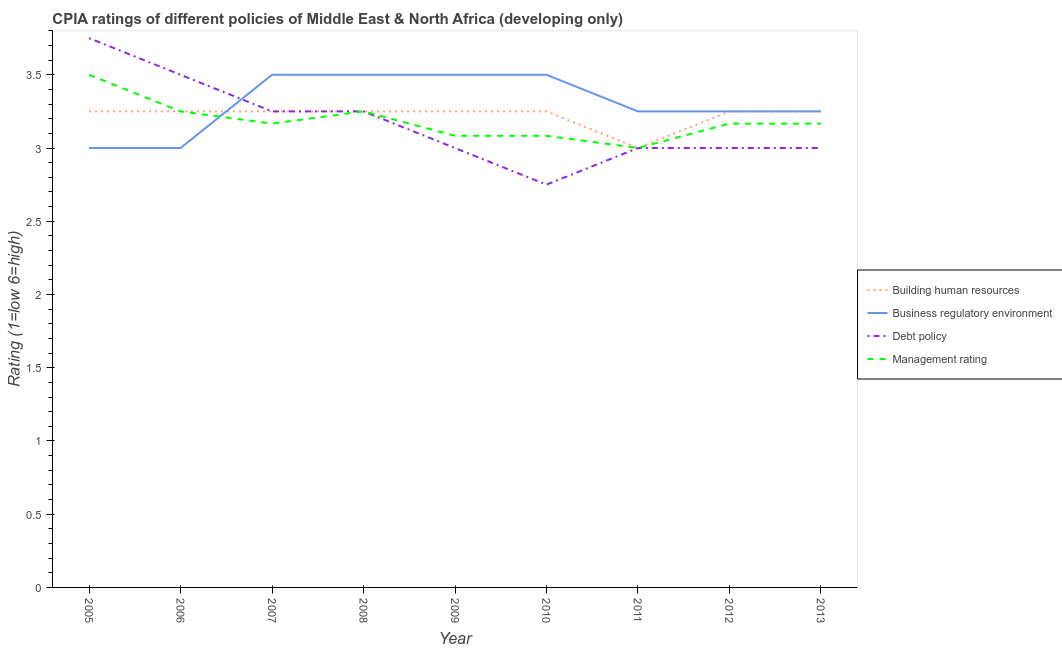Does the line corresponding to cpia rating of business regulatory environment intersect with the line corresponding to cpia rating of debt policy?
Your answer should be very brief. Yes. Across all years, what is the minimum cpia rating of management?
Your response must be concise. 3. In which year was the cpia rating of debt policy minimum?
Make the answer very short. 2010. What is the difference between the cpia rating of management in 2005 and that in 2009?
Provide a succinct answer. 0.42. What is the average cpia rating of management per year?
Your response must be concise. 3.19. In how many years, is the cpia rating of building human resources greater than 2.6?
Ensure brevity in your answer.  9. What is the ratio of the cpia rating of business regulatory environment in 2006 to that in 2011?
Provide a succinct answer. 0.92. Is the cpia rating of building human resources in 2007 less than that in 2009?
Your answer should be compact. No. Is the difference between the cpia rating of debt policy in 2008 and 2009 greater than the difference between the cpia rating of building human resources in 2008 and 2009?
Offer a very short reply. Yes. What is the difference between the highest and the second highest cpia rating of management?
Ensure brevity in your answer.  0.25. What is the difference between the highest and the lowest cpia rating of building human resources?
Ensure brevity in your answer.  0.25. In how many years, is the cpia rating of management greater than the average cpia rating of management taken over all years?
Give a very brief answer. 3. Is the sum of the cpia rating of debt policy in 2007 and 2010 greater than the maximum cpia rating of business regulatory environment across all years?
Offer a very short reply. Yes. How many lines are there?
Your answer should be compact. 4. Are the values on the major ticks of Y-axis written in scientific E-notation?
Give a very brief answer. No. Does the graph contain any zero values?
Your answer should be compact. No. Does the graph contain grids?
Ensure brevity in your answer.  No. Where does the legend appear in the graph?
Provide a succinct answer. Center right. How are the legend labels stacked?
Offer a very short reply. Vertical. What is the title of the graph?
Keep it short and to the point. CPIA ratings of different policies of Middle East & North Africa (developing only). Does "Public resource use" appear as one of the legend labels in the graph?
Give a very brief answer. No. What is the label or title of the X-axis?
Provide a succinct answer. Year. What is the Rating (1=low 6=high) in Building human resources in 2005?
Give a very brief answer. 3.25. What is the Rating (1=low 6=high) in Debt policy in 2005?
Make the answer very short. 3.75. What is the Rating (1=low 6=high) of Building human resources in 2006?
Make the answer very short. 3.25. What is the Rating (1=low 6=high) of Business regulatory environment in 2007?
Provide a short and direct response. 3.5. What is the Rating (1=low 6=high) of Management rating in 2007?
Make the answer very short. 3.17. What is the Rating (1=low 6=high) in Building human resources in 2008?
Offer a terse response. 3.25. What is the Rating (1=low 6=high) of Debt policy in 2008?
Provide a short and direct response. 3.25. What is the Rating (1=low 6=high) of Management rating in 2008?
Your answer should be very brief. 3.25. What is the Rating (1=low 6=high) of Building human resources in 2009?
Your response must be concise. 3.25. What is the Rating (1=low 6=high) in Debt policy in 2009?
Offer a very short reply. 3. What is the Rating (1=low 6=high) of Management rating in 2009?
Keep it short and to the point. 3.08. What is the Rating (1=low 6=high) in Building human resources in 2010?
Offer a terse response. 3.25. What is the Rating (1=low 6=high) of Debt policy in 2010?
Provide a short and direct response. 2.75. What is the Rating (1=low 6=high) of Management rating in 2010?
Offer a terse response. 3.08. What is the Rating (1=low 6=high) in Building human resources in 2011?
Offer a very short reply. 3. What is the Rating (1=low 6=high) in Business regulatory environment in 2011?
Provide a short and direct response. 3.25. What is the Rating (1=low 6=high) in Debt policy in 2011?
Make the answer very short. 3. What is the Rating (1=low 6=high) of Business regulatory environment in 2012?
Make the answer very short. 3.25. What is the Rating (1=low 6=high) in Management rating in 2012?
Offer a very short reply. 3.17. What is the Rating (1=low 6=high) in Management rating in 2013?
Provide a succinct answer. 3.17. Across all years, what is the maximum Rating (1=low 6=high) in Business regulatory environment?
Make the answer very short. 3.5. Across all years, what is the maximum Rating (1=low 6=high) of Debt policy?
Provide a succinct answer. 3.75. Across all years, what is the minimum Rating (1=low 6=high) of Debt policy?
Offer a terse response. 2.75. What is the total Rating (1=low 6=high) of Business regulatory environment in the graph?
Keep it short and to the point. 29.75. What is the total Rating (1=low 6=high) in Debt policy in the graph?
Provide a short and direct response. 28.5. What is the total Rating (1=low 6=high) of Management rating in the graph?
Provide a short and direct response. 28.67. What is the difference between the Rating (1=low 6=high) of Building human resources in 2005 and that in 2006?
Keep it short and to the point. 0. What is the difference between the Rating (1=low 6=high) in Business regulatory environment in 2005 and that in 2007?
Keep it short and to the point. -0.5. What is the difference between the Rating (1=low 6=high) of Business regulatory environment in 2005 and that in 2008?
Keep it short and to the point. -0.5. What is the difference between the Rating (1=low 6=high) of Management rating in 2005 and that in 2008?
Your answer should be very brief. 0.25. What is the difference between the Rating (1=low 6=high) of Building human resources in 2005 and that in 2009?
Your answer should be very brief. 0. What is the difference between the Rating (1=low 6=high) in Business regulatory environment in 2005 and that in 2009?
Your answer should be compact. -0.5. What is the difference between the Rating (1=low 6=high) of Management rating in 2005 and that in 2009?
Provide a succinct answer. 0.42. What is the difference between the Rating (1=low 6=high) in Business regulatory environment in 2005 and that in 2010?
Offer a very short reply. -0.5. What is the difference between the Rating (1=low 6=high) in Debt policy in 2005 and that in 2010?
Offer a terse response. 1. What is the difference between the Rating (1=low 6=high) of Management rating in 2005 and that in 2010?
Keep it short and to the point. 0.42. What is the difference between the Rating (1=low 6=high) in Debt policy in 2005 and that in 2011?
Give a very brief answer. 0.75. What is the difference between the Rating (1=low 6=high) of Management rating in 2005 and that in 2011?
Give a very brief answer. 0.5. What is the difference between the Rating (1=low 6=high) of Building human resources in 2005 and that in 2012?
Give a very brief answer. 0. What is the difference between the Rating (1=low 6=high) of Management rating in 2005 and that in 2013?
Offer a terse response. 0.33. What is the difference between the Rating (1=low 6=high) of Business regulatory environment in 2006 and that in 2007?
Your response must be concise. -0.5. What is the difference between the Rating (1=low 6=high) in Debt policy in 2006 and that in 2007?
Make the answer very short. 0.25. What is the difference between the Rating (1=low 6=high) in Management rating in 2006 and that in 2007?
Make the answer very short. 0.08. What is the difference between the Rating (1=low 6=high) in Building human resources in 2006 and that in 2008?
Ensure brevity in your answer.  0. What is the difference between the Rating (1=low 6=high) in Business regulatory environment in 2006 and that in 2008?
Provide a succinct answer. -0.5. What is the difference between the Rating (1=low 6=high) of Management rating in 2006 and that in 2008?
Give a very brief answer. 0. What is the difference between the Rating (1=low 6=high) in Building human resources in 2006 and that in 2009?
Keep it short and to the point. 0. What is the difference between the Rating (1=low 6=high) in Business regulatory environment in 2006 and that in 2009?
Ensure brevity in your answer.  -0.5. What is the difference between the Rating (1=low 6=high) of Management rating in 2006 and that in 2009?
Provide a short and direct response. 0.17. What is the difference between the Rating (1=low 6=high) in Debt policy in 2006 and that in 2010?
Your answer should be compact. 0.75. What is the difference between the Rating (1=low 6=high) of Management rating in 2006 and that in 2010?
Provide a short and direct response. 0.17. What is the difference between the Rating (1=low 6=high) of Building human resources in 2006 and that in 2011?
Your answer should be very brief. 0.25. What is the difference between the Rating (1=low 6=high) of Debt policy in 2006 and that in 2011?
Offer a terse response. 0.5. What is the difference between the Rating (1=low 6=high) in Debt policy in 2006 and that in 2012?
Give a very brief answer. 0.5. What is the difference between the Rating (1=low 6=high) of Management rating in 2006 and that in 2012?
Make the answer very short. 0.08. What is the difference between the Rating (1=low 6=high) in Building human resources in 2006 and that in 2013?
Provide a short and direct response. 0. What is the difference between the Rating (1=low 6=high) of Business regulatory environment in 2006 and that in 2013?
Your answer should be very brief. -0.25. What is the difference between the Rating (1=low 6=high) in Management rating in 2006 and that in 2013?
Make the answer very short. 0.08. What is the difference between the Rating (1=low 6=high) in Business regulatory environment in 2007 and that in 2008?
Give a very brief answer. 0. What is the difference between the Rating (1=low 6=high) in Management rating in 2007 and that in 2008?
Keep it short and to the point. -0.08. What is the difference between the Rating (1=low 6=high) of Management rating in 2007 and that in 2009?
Provide a short and direct response. 0.08. What is the difference between the Rating (1=low 6=high) of Building human resources in 2007 and that in 2010?
Your answer should be very brief. 0. What is the difference between the Rating (1=low 6=high) of Business regulatory environment in 2007 and that in 2010?
Keep it short and to the point. 0. What is the difference between the Rating (1=low 6=high) of Management rating in 2007 and that in 2010?
Your answer should be compact. 0.08. What is the difference between the Rating (1=low 6=high) of Debt policy in 2007 and that in 2011?
Your answer should be very brief. 0.25. What is the difference between the Rating (1=low 6=high) of Building human resources in 2007 and that in 2012?
Offer a very short reply. 0. What is the difference between the Rating (1=low 6=high) in Business regulatory environment in 2007 and that in 2012?
Provide a succinct answer. 0.25. What is the difference between the Rating (1=low 6=high) of Management rating in 2007 and that in 2012?
Offer a very short reply. 0. What is the difference between the Rating (1=low 6=high) of Debt policy in 2007 and that in 2013?
Your answer should be very brief. 0.25. What is the difference between the Rating (1=low 6=high) in Debt policy in 2008 and that in 2009?
Give a very brief answer. 0.25. What is the difference between the Rating (1=low 6=high) of Business regulatory environment in 2008 and that in 2010?
Offer a terse response. 0. What is the difference between the Rating (1=low 6=high) of Debt policy in 2008 and that in 2010?
Ensure brevity in your answer.  0.5. What is the difference between the Rating (1=low 6=high) of Management rating in 2008 and that in 2010?
Your answer should be compact. 0.17. What is the difference between the Rating (1=low 6=high) in Building human resources in 2008 and that in 2011?
Offer a very short reply. 0.25. What is the difference between the Rating (1=low 6=high) of Business regulatory environment in 2008 and that in 2011?
Make the answer very short. 0.25. What is the difference between the Rating (1=low 6=high) in Building human resources in 2008 and that in 2012?
Provide a succinct answer. 0. What is the difference between the Rating (1=low 6=high) of Business regulatory environment in 2008 and that in 2012?
Give a very brief answer. 0.25. What is the difference between the Rating (1=low 6=high) in Management rating in 2008 and that in 2012?
Provide a short and direct response. 0.08. What is the difference between the Rating (1=low 6=high) of Management rating in 2008 and that in 2013?
Give a very brief answer. 0.08. What is the difference between the Rating (1=low 6=high) of Debt policy in 2009 and that in 2010?
Offer a terse response. 0.25. What is the difference between the Rating (1=low 6=high) in Building human resources in 2009 and that in 2011?
Provide a succinct answer. 0.25. What is the difference between the Rating (1=low 6=high) of Management rating in 2009 and that in 2011?
Your response must be concise. 0.08. What is the difference between the Rating (1=low 6=high) of Building human resources in 2009 and that in 2012?
Give a very brief answer. 0. What is the difference between the Rating (1=low 6=high) in Management rating in 2009 and that in 2012?
Your answer should be compact. -0.08. What is the difference between the Rating (1=low 6=high) in Management rating in 2009 and that in 2013?
Provide a succinct answer. -0.08. What is the difference between the Rating (1=low 6=high) of Debt policy in 2010 and that in 2011?
Offer a very short reply. -0.25. What is the difference between the Rating (1=low 6=high) in Management rating in 2010 and that in 2011?
Provide a succinct answer. 0.08. What is the difference between the Rating (1=low 6=high) in Business regulatory environment in 2010 and that in 2012?
Offer a very short reply. 0.25. What is the difference between the Rating (1=low 6=high) of Debt policy in 2010 and that in 2012?
Provide a short and direct response. -0.25. What is the difference between the Rating (1=low 6=high) in Management rating in 2010 and that in 2012?
Keep it short and to the point. -0.08. What is the difference between the Rating (1=low 6=high) in Business regulatory environment in 2010 and that in 2013?
Provide a short and direct response. 0.25. What is the difference between the Rating (1=low 6=high) in Management rating in 2010 and that in 2013?
Your answer should be very brief. -0.08. What is the difference between the Rating (1=low 6=high) of Building human resources in 2011 and that in 2012?
Offer a terse response. -0.25. What is the difference between the Rating (1=low 6=high) of Business regulatory environment in 2011 and that in 2012?
Keep it short and to the point. 0. What is the difference between the Rating (1=low 6=high) in Debt policy in 2011 and that in 2012?
Provide a short and direct response. 0. What is the difference between the Rating (1=low 6=high) of Building human resources in 2011 and that in 2013?
Ensure brevity in your answer.  -0.25. What is the difference between the Rating (1=low 6=high) in Management rating in 2011 and that in 2013?
Your answer should be compact. -0.17. What is the difference between the Rating (1=low 6=high) in Building human resources in 2012 and that in 2013?
Your answer should be compact. 0. What is the difference between the Rating (1=low 6=high) in Business regulatory environment in 2012 and that in 2013?
Your answer should be compact. 0. What is the difference between the Rating (1=low 6=high) in Debt policy in 2012 and that in 2013?
Ensure brevity in your answer.  0. What is the difference between the Rating (1=low 6=high) in Management rating in 2012 and that in 2013?
Make the answer very short. 0. What is the difference between the Rating (1=low 6=high) of Building human resources in 2005 and the Rating (1=low 6=high) of Business regulatory environment in 2006?
Provide a short and direct response. 0.25. What is the difference between the Rating (1=low 6=high) in Building human resources in 2005 and the Rating (1=low 6=high) in Management rating in 2006?
Your answer should be very brief. 0. What is the difference between the Rating (1=low 6=high) in Business regulatory environment in 2005 and the Rating (1=low 6=high) in Debt policy in 2006?
Your answer should be very brief. -0.5. What is the difference between the Rating (1=low 6=high) in Building human resources in 2005 and the Rating (1=low 6=high) in Business regulatory environment in 2007?
Make the answer very short. -0.25. What is the difference between the Rating (1=low 6=high) in Building human resources in 2005 and the Rating (1=low 6=high) in Management rating in 2007?
Offer a terse response. 0.08. What is the difference between the Rating (1=low 6=high) in Business regulatory environment in 2005 and the Rating (1=low 6=high) in Debt policy in 2007?
Your response must be concise. -0.25. What is the difference between the Rating (1=low 6=high) in Debt policy in 2005 and the Rating (1=low 6=high) in Management rating in 2007?
Your response must be concise. 0.58. What is the difference between the Rating (1=low 6=high) of Building human resources in 2005 and the Rating (1=low 6=high) of Management rating in 2008?
Your answer should be very brief. 0. What is the difference between the Rating (1=low 6=high) in Debt policy in 2005 and the Rating (1=low 6=high) in Management rating in 2008?
Your answer should be very brief. 0.5. What is the difference between the Rating (1=low 6=high) of Building human resources in 2005 and the Rating (1=low 6=high) of Business regulatory environment in 2009?
Your answer should be very brief. -0.25. What is the difference between the Rating (1=low 6=high) of Business regulatory environment in 2005 and the Rating (1=low 6=high) of Debt policy in 2009?
Offer a terse response. 0. What is the difference between the Rating (1=low 6=high) in Business regulatory environment in 2005 and the Rating (1=low 6=high) in Management rating in 2009?
Provide a succinct answer. -0.08. What is the difference between the Rating (1=low 6=high) of Debt policy in 2005 and the Rating (1=low 6=high) of Management rating in 2009?
Your answer should be compact. 0.67. What is the difference between the Rating (1=low 6=high) in Building human resources in 2005 and the Rating (1=low 6=high) in Debt policy in 2010?
Ensure brevity in your answer.  0.5. What is the difference between the Rating (1=low 6=high) of Business regulatory environment in 2005 and the Rating (1=low 6=high) of Debt policy in 2010?
Give a very brief answer. 0.25. What is the difference between the Rating (1=low 6=high) of Business regulatory environment in 2005 and the Rating (1=low 6=high) of Management rating in 2010?
Keep it short and to the point. -0.08. What is the difference between the Rating (1=low 6=high) of Building human resources in 2005 and the Rating (1=low 6=high) of Business regulatory environment in 2011?
Offer a terse response. 0. What is the difference between the Rating (1=low 6=high) in Building human resources in 2005 and the Rating (1=low 6=high) in Debt policy in 2011?
Provide a succinct answer. 0.25. What is the difference between the Rating (1=low 6=high) of Debt policy in 2005 and the Rating (1=low 6=high) of Management rating in 2011?
Make the answer very short. 0.75. What is the difference between the Rating (1=low 6=high) in Building human resources in 2005 and the Rating (1=low 6=high) in Business regulatory environment in 2012?
Keep it short and to the point. 0. What is the difference between the Rating (1=low 6=high) in Building human resources in 2005 and the Rating (1=low 6=high) in Management rating in 2012?
Offer a very short reply. 0.08. What is the difference between the Rating (1=low 6=high) in Business regulatory environment in 2005 and the Rating (1=low 6=high) in Debt policy in 2012?
Your answer should be very brief. 0. What is the difference between the Rating (1=low 6=high) in Debt policy in 2005 and the Rating (1=low 6=high) in Management rating in 2012?
Give a very brief answer. 0.58. What is the difference between the Rating (1=low 6=high) of Building human resources in 2005 and the Rating (1=low 6=high) of Business regulatory environment in 2013?
Offer a terse response. 0. What is the difference between the Rating (1=low 6=high) of Building human resources in 2005 and the Rating (1=low 6=high) of Debt policy in 2013?
Keep it short and to the point. 0.25. What is the difference between the Rating (1=low 6=high) in Building human resources in 2005 and the Rating (1=low 6=high) in Management rating in 2013?
Offer a very short reply. 0.08. What is the difference between the Rating (1=low 6=high) of Business regulatory environment in 2005 and the Rating (1=low 6=high) of Debt policy in 2013?
Provide a succinct answer. 0. What is the difference between the Rating (1=low 6=high) in Business regulatory environment in 2005 and the Rating (1=low 6=high) in Management rating in 2013?
Provide a succinct answer. -0.17. What is the difference between the Rating (1=low 6=high) in Debt policy in 2005 and the Rating (1=low 6=high) in Management rating in 2013?
Offer a terse response. 0.58. What is the difference between the Rating (1=low 6=high) in Building human resources in 2006 and the Rating (1=low 6=high) in Management rating in 2007?
Provide a succinct answer. 0.08. What is the difference between the Rating (1=low 6=high) of Debt policy in 2006 and the Rating (1=low 6=high) of Management rating in 2007?
Your response must be concise. 0.33. What is the difference between the Rating (1=low 6=high) in Building human resources in 2006 and the Rating (1=low 6=high) in Business regulatory environment in 2008?
Give a very brief answer. -0.25. What is the difference between the Rating (1=low 6=high) of Building human resources in 2006 and the Rating (1=low 6=high) of Debt policy in 2008?
Provide a succinct answer. 0. What is the difference between the Rating (1=low 6=high) in Business regulatory environment in 2006 and the Rating (1=low 6=high) in Debt policy in 2008?
Keep it short and to the point. -0.25. What is the difference between the Rating (1=low 6=high) in Building human resources in 2006 and the Rating (1=low 6=high) in Business regulatory environment in 2009?
Your answer should be very brief. -0.25. What is the difference between the Rating (1=low 6=high) in Building human resources in 2006 and the Rating (1=low 6=high) in Debt policy in 2009?
Provide a short and direct response. 0.25. What is the difference between the Rating (1=low 6=high) in Business regulatory environment in 2006 and the Rating (1=low 6=high) in Debt policy in 2009?
Keep it short and to the point. 0. What is the difference between the Rating (1=low 6=high) in Business regulatory environment in 2006 and the Rating (1=low 6=high) in Management rating in 2009?
Your response must be concise. -0.08. What is the difference between the Rating (1=low 6=high) in Debt policy in 2006 and the Rating (1=low 6=high) in Management rating in 2009?
Your response must be concise. 0.42. What is the difference between the Rating (1=low 6=high) in Building human resources in 2006 and the Rating (1=low 6=high) in Management rating in 2010?
Keep it short and to the point. 0.17. What is the difference between the Rating (1=low 6=high) of Business regulatory environment in 2006 and the Rating (1=low 6=high) of Debt policy in 2010?
Your answer should be very brief. 0.25. What is the difference between the Rating (1=low 6=high) in Business regulatory environment in 2006 and the Rating (1=low 6=high) in Management rating in 2010?
Keep it short and to the point. -0.08. What is the difference between the Rating (1=low 6=high) of Debt policy in 2006 and the Rating (1=low 6=high) of Management rating in 2010?
Give a very brief answer. 0.42. What is the difference between the Rating (1=low 6=high) of Building human resources in 2006 and the Rating (1=low 6=high) of Business regulatory environment in 2011?
Offer a very short reply. 0. What is the difference between the Rating (1=low 6=high) of Business regulatory environment in 2006 and the Rating (1=low 6=high) of Management rating in 2011?
Make the answer very short. 0. What is the difference between the Rating (1=low 6=high) of Debt policy in 2006 and the Rating (1=low 6=high) of Management rating in 2011?
Your response must be concise. 0.5. What is the difference between the Rating (1=low 6=high) in Building human resources in 2006 and the Rating (1=low 6=high) in Debt policy in 2012?
Your answer should be very brief. 0.25. What is the difference between the Rating (1=low 6=high) in Building human resources in 2006 and the Rating (1=low 6=high) in Management rating in 2012?
Give a very brief answer. 0.08. What is the difference between the Rating (1=low 6=high) of Business regulatory environment in 2006 and the Rating (1=low 6=high) of Management rating in 2012?
Your answer should be compact. -0.17. What is the difference between the Rating (1=low 6=high) in Debt policy in 2006 and the Rating (1=low 6=high) in Management rating in 2012?
Make the answer very short. 0.33. What is the difference between the Rating (1=low 6=high) of Building human resources in 2006 and the Rating (1=low 6=high) of Debt policy in 2013?
Provide a short and direct response. 0.25. What is the difference between the Rating (1=low 6=high) in Building human resources in 2006 and the Rating (1=low 6=high) in Management rating in 2013?
Your response must be concise. 0.08. What is the difference between the Rating (1=low 6=high) in Debt policy in 2006 and the Rating (1=low 6=high) in Management rating in 2013?
Keep it short and to the point. 0.33. What is the difference between the Rating (1=low 6=high) of Business regulatory environment in 2007 and the Rating (1=low 6=high) of Debt policy in 2008?
Keep it short and to the point. 0.25. What is the difference between the Rating (1=low 6=high) of Business regulatory environment in 2007 and the Rating (1=low 6=high) of Management rating in 2008?
Offer a very short reply. 0.25. What is the difference between the Rating (1=low 6=high) of Debt policy in 2007 and the Rating (1=low 6=high) of Management rating in 2008?
Offer a very short reply. 0. What is the difference between the Rating (1=low 6=high) of Building human resources in 2007 and the Rating (1=low 6=high) of Business regulatory environment in 2009?
Ensure brevity in your answer.  -0.25. What is the difference between the Rating (1=low 6=high) in Business regulatory environment in 2007 and the Rating (1=low 6=high) in Management rating in 2009?
Give a very brief answer. 0.42. What is the difference between the Rating (1=low 6=high) of Debt policy in 2007 and the Rating (1=low 6=high) of Management rating in 2009?
Give a very brief answer. 0.17. What is the difference between the Rating (1=low 6=high) in Business regulatory environment in 2007 and the Rating (1=low 6=high) in Management rating in 2010?
Give a very brief answer. 0.42. What is the difference between the Rating (1=low 6=high) of Building human resources in 2007 and the Rating (1=low 6=high) of Business regulatory environment in 2011?
Make the answer very short. 0. What is the difference between the Rating (1=low 6=high) of Building human resources in 2007 and the Rating (1=low 6=high) of Debt policy in 2011?
Provide a short and direct response. 0.25. What is the difference between the Rating (1=low 6=high) in Business regulatory environment in 2007 and the Rating (1=low 6=high) in Debt policy in 2011?
Provide a short and direct response. 0.5. What is the difference between the Rating (1=low 6=high) of Building human resources in 2007 and the Rating (1=low 6=high) of Debt policy in 2012?
Keep it short and to the point. 0.25. What is the difference between the Rating (1=low 6=high) in Building human resources in 2007 and the Rating (1=low 6=high) in Management rating in 2012?
Make the answer very short. 0.08. What is the difference between the Rating (1=low 6=high) of Business regulatory environment in 2007 and the Rating (1=low 6=high) of Debt policy in 2012?
Your response must be concise. 0.5. What is the difference between the Rating (1=low 6=high) of Debt policy in 2007 and the Rating (1=low 6=high) of Management rating in 2012?
Your answer should be compact. 0.08. What is the difference between the Rating (1=low 6=high) in Building human resources in 2007 and the Rating (1=low 6=high) in Debt policy in 2013?
Offer a terse response. 0.25. What is the difference between the Rating (1=low 6=high) of Building human resources in 2007 and the Rating (1=low 6=high) of Management rating in 2013?
Offer a terse response. 0.08. What is the difference between the Rating (1=low 6=high) of Debt policy in 2007 and the Rating (1=low 6=high) of Management rating in 2013?
Ensure brevity in your answer.  0.08. What is the difference between the Rating (1=low 6=high) in Building human resources in 2008 and the Rating (1=low 6=high) in Management rating in 2009?
Your answer should be compact. 0.17. What is the difference between the Rating (1=low 6=high) of Business regulatory environment in 2008 and the Rating (1=low 6=high) of Debt policy in 2009?
Keep it short and to the point. 0.5. What is the difference between the Rating (1=low 6=high) of Business regulatory environment in 2008 and the Rating (1=low 6=high) of Management rating in 2009?
Provide a short and direct response. 0.42. What is the difference between the Rating (1=low 6=high) in Building human resources in 2008 and the Rating (1=low 6=high) in Business regulatory environment in 2010?
Keep it short and to the point. -0.25. What is the difference between the Rating (1=low 6=high) of Building human resources in 2008 and the Rating (1=low 6=high) of Debt policy in 2010?
Offer a terse response. 0.5. What is the difference between the Rating (1=low 6=high) of Building human resources in 2008 and the Rating (1=low 6=high) of Management rating in 2010?
Offer a terse response. 0.17. What is the difference between the Rating (1=low 6=high) in Business regulatory environment in 2008 and the Rating (1=low 6=high) in Management rating in 2010?
Ensure brevity in your answer.  0.42. What is the difference between the Rating (1=low 6=high) in Debt policy in 2008 and the Rating (1=low 6=high) in Management rating in 2010?
Offer a very short reply. 0.17. What is the difference between the Rating (1=low 6=high) of Building human resources in 2008 and the Rating (1=low 6=high) of Business regulatory environment in 2011?
Provide a succinct answer. 0. What is the difference between the Rating (1=low 6=high) of Building human resources in 2008 and the Rating (1=low 6=high) of Management rating in 2011?
Your answer should be compact. 0.25. What is the difference between the Rating (1=low 6=high) in Business regulatory environment in 2008 and the Rating (1=low 6=high) in Debt policy in 2011?
Your response must be concise. 0.5. What is the difference between the Rating (1=low 6=high) in Business regulatory environment in 2008 and the Rating (1=low 6=high) in Management rating in 2011?
Your answer should be compact. 0.5. What is the difference between the Rating (1=low 6=high) of Debt policy in 2008 and the Rating (1=low 6=high) of Management rating in 2011?
Ensure brevity in your answer.  0.25. What is the difference between the Rating (1=low 6=high) of Building human resources in 2008 and the Rating (1=low 6=high) of Management rating in 2012?
Your answer should be very brief. 0.08. What is the difference between the Rating (1=low 6=high) in Debt policy in 2008 and the Rating (1=low 6=high) in Management rating in 2012?
Your answer should be very brief. 0.08. What is the difference between the Rating (1=low 6=high) in Building human resources in 2008 and the Rating (1=low 6=high) in Business regulatory environment in 2013?
Make the answer very short. 0. What is the difference between the Rating (1=low 6=high) in Building human resources in 2008 and the Rating (1=low 6=high) in Debt policy in 2013?
Give a very brief answer. 0.25. What is the difference between the Rating (1=low 6=high) in Building human resources in 2008 and the Rating (1=low 6=high) in Management rating in 2013?
Make the answer very short. 0.08. What is the difference between the Rating (1=low 6=high) of Business regulatory environment in 2008 and the Rating (1=low 6=high) of Debt policy in 2013?
Give a very brief answer. 0.5. What is the difference between the Rating (1=low 6=high) in Business regulatory environment in 2008 and the Rating (1=low 6=high) in Management rating in 2013?
Offer a terse response. 0.33. What is the difference between the Rating (1=low 6=high) of Debt policy in 2008 and the Rating (1=low 6=high) of Management rating in 2013?
Your answer should be compact. 0.08. What is the difference between the Rating (1=low 6=high) of Building human resources in 2009 and the Rating (1=low 6=high) of Business regulatory environment in 2010?
Offer a terse response. -0.25. What is the difference between the Rating (1=low 6=high) of Building human resources in 2009 and the Rating (1=low 6=high) of Management rating in 2010?
Offer a very short reply. 0.17. What is the difference between the Rating (1=low 6=high) in Business regulatory environment in 2009 and the Rating (1=low 6=high) in Management rating in 2010?
Provide a succinct answer. 0.42. What is the difference between the Rating (1=low 6=high) of Debt policy in 2009 and the Rating (1=low 6=high) of Management rating in 2010?
Your answer should be compact. -0.08. What is the difference between the Rating (1=low 6=high) in Building human resources in 2009 and the Rating (1=low 6=high) in Management rating in 2011?
Your answer should be compact. 0.25. What is the difference between the Rating (1=low 6=high) of Business regulatory environment in 2009 and the Rating (1=low 6=high) of Management rating in 2011?
Your answer should be compact. 0.5. What is the difference between the Rating (1=low 6=high) of Building human resources in 2009 and the Rating (1=low 6=high) of Debt policy in 2012?
Ensure brevity in your answer.  0.25. What is the difference between the Rating (1=low 6=high) in Building human resources in 2009 and the Rating (1=low 6=high) in Management rating in 2012?
Provide a succinct answer. 0.08. What is the difference between the Rating (1=low 6=high) in Business regulatory environment in 2009 and the Rating (1=low 6=high) in Debt policy in 2012?
Provide a short and direct response. 0.5. What is the difference between the Rating (1=low 6=high) of Business regulatory environment in 2009 and the Rating (1=low 6=high) of Management rating in 2012?
Give a very brief answer. 0.33. What is the difference between the Rating (1=low 6=high) of Debt policy in 2009 and the Rating (1=low 6=high) of Management rating in 2012?
Make the answer very short. -0.17. What is the difference between the Rating (1=low 6=high) in Building human resources in 2009 and the Rating (1=low 6=high) in Business regulatory environment in 2013?
Offer a terse response. 0. What is the difference between the Rating (1=low 6=high) of Building human resources in 2009 and the Rating (1=low 6=high) of Management rating in 2013?
Provide a succinct answer. 0.08. What is the difference between the Rating (1=low 6=high) of Business regulatory environment in 2009 and the Rating (1=low 6=high) of Debt policy in 2013?
Ensure brevity in your answer.  0.5. What is the difference between the Rating (1=low 6=high) in Debt policy in 2009 and the Rating (1=low 6=high) in Management rating in 2013?
Make the answer very short. -0.17. What is the difference between the Rating (1=low 6=high) in Business regulatory environment in 2010 and the Rating (1=low 6=high) in Management rating in 2011?
Ensure brevity in your answer.  0.5. What is the difference between the Rating (1=low 6=high) in Debt policy in 2010 and the Rating (1=low 6=high) in Management rating in 2011?
Keep it short and to the point. -0.25. What is the difference between the Rating (1=low 6=high) of Building human resources in 2010 and the Rating (1=low 6=high) of Management rating in 2012?
Provide a short and direct response. 0.08. What is the difference between the Rating (1=low 6=high) in Business regulatory environment in 2010 and the Rating (1=low 6=high) in Management rating in 2012?
Offer a very short reply. 0.33. What is the difference between the Rating (1=low 6=high) in Debt policy in 2010 and the Rating (1=low 6=high) in Management rating in 2012?
Your answer should be very brief. -0.42. What is the difference between the Rating (1=low 6=high) in Building human resources in 2010 and the Rating (1=low 6=high) in Business regulatory environment in 2013?
Keep it short and to the point. 0. What is the difference between the Rating (1=low 6=high) in Building human resources in 2010 and the Rating (1=low 6=high) in Debt policy in 2013?
Make the answer very short. 0.25. What is the difference between the Rating (1=low 6=high) of Building human resources in 2010 and the Rating (1=low 6=high) of Management rating in 2013?
Provide a short and direct response. 0.08. What is the difference between the Rating (1=low 6=high) in Business regulatory environment in 2010 and the Rating (1=low 6=high) in Management rating in 2013?
Your answer should be compact. 0.33. What is the difference between the Rating (1=low 6=high) of Debt policy in 2010 and the Rating (1=low 6=high) of Management rating in 2013?
Provide a short and direct response. -0.42. What is the difference between the Rating (1=low 6=high) of Building human resources in 2011 and the Rating (1=low 6=high) of Business regulatory environment in 2012?
Provide a short and direct response. -0.25. What is the difference between the Rating (1=low 6=high) in Building human resources in 2011 and the Rating (1=low 6=high) in Debt policy in 2012?
Make the answer very short. 0. What is the difference between the Rating (1=low 6=high) of Business regulatory environment in 2011 and the Rating (1=low 6=high) of Management rating in 2012?
Ensure brevity in your answer.  0.08. What is the difference between the Rating (1=low 6=high) of Debt policy in 2011 and the Rating (1=low 6=high) of Management rating in 2012?
Offer a terse response. -0.17. What is the difference between the Rating (1=low 6=high) in Building human resources in 2011 and the Rating (1=low 6=high) in Management rating in 2013?
Give a very brief answer. -0.17. What is the difference between the Rating (1=low 6=high) in Business regulatory environment in 2011 and the Rating (1=low 6=high) in Debt policy in 2013?
Your answer should be very brief. 0.25. What is the difference between the Rating (1=low 6=high) in Business regulatory environment in 2011 and the Rating (1=low 6=high) in Management rating in 2013?
Offer a terse response. 0.08. What is the difference between the Rating (1=low 6=high) of Debt policy in 2011 and the Rating (1=low 6=high) of Management rating in 2013?
Your answer should be very brief. -0.17. What is the difference between the Rating (1=low 6=high) in Building human resources in 2012 and the Rating (1=low 6=high) in Business regulatory environment in 2013?
Ensure brevity in your answer.  0. What is the difference between the Rating (1=low 6=high) in Building human resources in 2012 and the Rating (1=low 6=high) in Debt policy in 2013?
Offer a very short reply. 0.25. What is the difference between the Rating (1=low 6=high) in Building human resources in 2012 and the Rating (1=low 6=high) in Management rating in 2013?
Offer a terse response. 0.08. What is the difference between the Rating (1=low 6=high) of Business regulatory environment in 2012 and the Rating (1=low 6=high) of Debt policy in 2013?
Make the answer very short. 0.25. What is the difference between the Rating (1=low 6=high) of Business regulatory environment in 2012 and the Rating (1=low 6=high) of Management rating in 2013?
Provide a succinct answer. 0.08. What is the average Rating (1=low 6=high) in Building human resources per year?
Your answer should be very brief. 3.22. What is the average Rating (1=low 6=high) in Business regulatory environment per year?
Your answer should be compact. 3.31. What is the average Rating (1=low 6=high) in Debt policy per year?
Ensure brevity in your answer.  3.17. What is the average Rating (1=low 6=high) of Management rating per year?
Ensure brevity in your answer.  3.19. In the year 2005, what is the difference between the Rating (1=low 6=high) in Building human resources and Rating (1=low 6=high) in Debt policy?
Keep it short and to the point. -0.5. In the year 2005, what is the difference between the Rating (1=low 6=high) in Business regulatory environment and Rating (1=low 6=high) in Debt policy?
Keep it short and to the point. -0.75. In the year 2005, what is the difference between the Rating (1=low 6=high) of Debt policy and Rating (1=low 6=high) of Management rating?
Offer a terse response. 0.25. In the year 2006, what is the difference between the Rating (1=low 6=high) in Building human resources and Rating (1=low 6=high) in Debt policy?
Your answer should be compact. -0.25. In the year 2006, what is the difference between the Rating (1=low 6=high) in Building human resources and Rating (1=low 6=high) in Management rating?
Offer a very short reply. 0. In the year 2007, what is the difference between the Rating (1=low 6=high) of Building human resources and Rating (1=low 6=high) of Debt policy?
Your response must be concise. 0. In the year 2007, what is the difference between the Rating (1=low 6=high) of Building human resources and Rating (1=low 6=high) of Management rating?
Offer a terse response. 0.08. In the year 2007, what is the difference between the Rating (1=low 6=high) of Business regulatory environment and Rating (1=low 6=high) of Management rating?
Your answer should be very brief. 0.33. In the year 2007, what is the difference between the Rating (1=low 6=high) of Debt policy and Rating (1=low 6=high) of Management rating?
Your response must be concise. 0.08. In the year 2008, what is the difference between the Rating (1=low 6=high) in Business regulatory environment and Rating (1=low 6=high) in Debt policy?
Keep it short and to the point. 0.25. In the year 2008, what is the difference between the Rating (1=low 6=high) of Business regulatory environment and Rating (1=low 6=high) of Management rating?
Offer a terse response. 0.25. In the year 2009, what is the difference between the Rating (1=low 6=high) in Building human resources and Rating (1=low 6=high) in Management rating?
Offer a terse response. 0.17. In the year 2009, what is the difference between the Rating (1=low 6=high) in Business regulatory environment and Rating (1=low 6=high) in Management rating?
Give a very brief answer. 0.42. In the year 2009, what is the difference between the Rating (1=low 6=high) of Debt policy and Rating (1=low 6=high) of Management rating?
Give a very brief answer. -0.08. In the year 2010, what is the difference between the Rating (1=low 6=high) of Building human resources and Rating (1=low 6=high) of Business regulatory environment?
Keep it short and to the point. -0.25. In the year 2010, what is the difference between the Rating (1=low 6=high) of Business regulatory environment and Rating (1=low 6=high) of Management rating?
Provide a succinct answer. 0.42. In the year 2011, what is the difference between the Rating (1=low 6=high) of Building human resources and Rating (1=low 6=high) of Business regulatory environment?
Provide a short and direct response. -0.25. In the year 2011, what is the difference between the Rating (1=low 6=high) of Building human resources and Rating (1=low 6=high) of Debt policy?
Offer a terse response. 0. In the year 2011, what is the difference between the Rating (1=low 6=high) in Business regulatory environment and Rating (1=low 6=high) in Debt policy?
Offer a terse response. 0.25. In the year 2011, what is the difference between the Rating (1=low 6=high) of Business regulatory environment and Rating (1=low 6=high) of Management rating?
Your answer should be very brief. 0.25. In the year 2011, what is the difference between the Rating (1=low 6=high) in Debt policy and Rating (1=low 6=high) in Management rating?
Keep it short and to the point. 0. In the year 2012, what is the difference between the Rating (1=low 6=high) in Building human resources and Rating (1=low 6=high) in Debt policy?
Provide a succinct answer. 0.25. In the year 2012, what is the difference between the Rating (1=low 6=high) in Building human resources and Rating (1=low 6=high) in Management rating?
Offer a very short reply. 0.08. In the year 2012, what is the difference between the Rating (1=low 6=high) in Business regulatory environment and Rating (1=low 6=high) in Management rating?
Your answer should be very brief. 0.08. In the year 2013, what is the difference between the Rating (1=low 6=high) in Building human resources and Rating (1=low 6=high) in Business regulatory environment?
Your response must be concise. 0. In the year 2013, what is the difference between the Rating (1=low 6=high) of Building human resources and Rating (1=low 6=high) of Debt policy?
Your answer should be compact. 0.25. In the year 2013, what is the difference between the Rating (1=low 6=high) of Building human resources and Rating (1=low 6=high) of Management rating?
Make the answer very short. 0.08. In the year 2013, what is the difference between the Rating (1=low 6=high) in Business regulatory environment and Rating (1=low 6=high) in Management rating?
Give a very brief answer. 0.08. In the year 2013, what is the difference between the Rating (1=low 6=high) in Debt policy and Rating (1=low 6=high) in Management rating?
Your answer should be compact. -0.17. What is the ratio of the Rating (1=low 6=high) of Debt policy in 2005 to that in 2006?
Provide a succinct answer. 1.07. What is the ratio of the Rating (1=low 6=high) of Debt policy in 2005 to that in 2007?
Make the answer very short. 1.15. What is the ratio of the Rating (1=low 6=high) of Management rating in 2005 to that in 2007?
Your response must be concise. 1.11. What is the ratio of the Rating (1=low 6=high) in Debt policy in 2005 to that in 2008?
Provide a succinct answer. 1.15. What is the ratio of the Rating (1=low 6=high) in Building human resources in 2005 to that in 2009?
Make the answer very short. 1. What is the ratio of the Rating (1=low 6=high) in Management rating in 2005 to that in 2009?
Keep it short and to the point. 1.14. What is the ratio of the Rating (1=low 6=high) in Building human resources in 2005 to that in 2010?
Make the answer very short. 1. What is the ratio of the Rating (1=low 6=high) of Debt policy in 2005 to that in 2010?
Your answer should be compact. 1.36. What is the ratio of the Rating (1=low 6=high) of Management rating in 2005 to that in 2010?
Your answer should be compact. 1.14. What is the ratio of the Rating (1=low 6=high) of Building human resources in 2005 to that in 2011?
Make the answer very short. 1.08. What is the ratio of the Rating (1=low 6=high) of Debt policy in 2005 to that in 2011?
Your answer should be very brief. 1.25. What is the ratio of the Rating (1=low 6=high) of Management rating in 2005 to that in 2011?
Provide a short and direct response. 1.17. What is the ratio of the Rating (1=low 6=high) in Management rating in 2005 to that in 2012?
Give a very brief answer. 1.11. What is the ratio of the Rating (1=low 6=high) of Debt policy in 2005 to that in 2013?
Ensure brevity in your answer.  1.25. What is the ratio of the Rating (1=low 6=high) in Management rating in 2005 to that in 2013?
Provide a short and direct response. 1.11. What is the ratio of the Rating (1=low 6=high) of Business regulatory environment in 2006 to that in 2007?
Ensure brevity in your answer.  0.86. What is the ratio of the Rating (1=low 6=high) of Debt policy in 2006 to that in 2007?
Give a very brief answer. 1.08. What is the ratio of the Rating (1=low 6=high) of Management rating in 2006 to that in 2007?
Your answer should be very brief. 1.03. What is the ratio of the Rating (1=low 6=high) of Building human resources in 2006 to that in 2008?
Offer a terse response. 1. What is the ratio of the Rating (1=low 6=high) in Business regulatory environment in 2006 to that in 2008?
Give a very brief answer. 0.86. What is the ratio of the Rating (1=low 6=high) of Building human resources in 2006 to that in 2009?
Your answer should be very brief. 1. What is the ratio of the Rating (1=low 6=high) in Debt policy in 2006 to that in 2009?
Your response must be concise. 1.17. What is the ratio of the Rating (1=low 6=high) in Management rating in 2006 to that in 2009?
Your answer should be very brief. 1.05. What is the ratio of the Rating (1=low 6=high) of Debt policy in 2006 to that in 2010?
Provide a short and direct response. 1.27. What is the ratio of the Rating (1=low 6=high) in Management rating in 2006 to that in 2010?
Provide a short and direct response. 1.05. What is the ratio of the Rating (1=low 6=high) of Debt policy in 2006 to that in 2011?
Make the answer very short. 1.17. What is the ratio of the Rating (1=low 6=high) of Management rating in 2006 to that in 2011?
Give a very brief answer. 1.08. What is the ratio of the Rating (1=low 6=high) in Building human resources in 2006 to that in 2012?
Your response must be concise. 1. What is the ratio of the Rating (1=low 6=high) of Debt policy in 2006 to that in 2012?
Your answer should be very brief. 1.17. What is the ratio of the Rating (1=low 6=high) of Management rating in 2006 to that in 2012?
Offer a very short reply. 1.03. What is the ratio of the Rating (1=low 6=high) in Building human resources in 2006 to that in 2013?
Provide a short and direct response. 1. What is the ratio of the Rating (1=low 6=high) in Management rating in 2006 to that in 2013?
Provide a short and direct response. 1.03. What is the ratio of the Rating (1=low 6=high) of Building human resources in 2007 to that in 2008?
Provide a short and direct response. 1. What is the ratio of the Rating (1=low 6=high) in Management rating in 2007 to that in 2008?
Your answer should be compact. 0.97. What is the ratio of the Rating (1=low 6=high) of Management rating in 2007 to that in 2009?
Offer a terse response. 1.03. What is the ratio of the Rating (1=low 6=high) in Building human resources in 2007 to that in 2010?
Your answer should be compact. 1. What is the ratio of the Rating (1=low 6=high) of Business regulatory environment in 2007 to that in 2010?
Ensure brevity in your answer.  1. What is the ratio of the Rating (1=low 6=high) in Debt policy in 2007 to that in 2010?
Keep it short and to the point. 1.18. What is the ratio of the Rating (1=low 6=high) in Building human resources in 2007 to that in 2011?
Your answer should be compact. 1.08. What is the ratio of the Rating (1=low 6=high) in Management rating in 2007 to that in 2011?
Offer a very short reply. 1.06. What is the ratio of the Rating (1=low 6=high) in Business regulatory environment in 2007 to that in 2012?
Ensure brevity in your answer.  1.08. What is the ratio of the Rating (1=low 6=high) in Debt policy in 2007 to that in 2012?
Your answer should be compact. 1.08. What is the ratio of the Rating (1=low 6=high) of Building human resources in 2007 to that in 2013?
Make the answer very short. 1. What is the ratio of the Rating (1=low 6=high) of Business regulatory environment in 2007 to that in 2013?
Offer a terse response. 1.08. What is the ratio of the Rating (1=low 6=high) of Management rating in 2007 to that in 2013?
Your response must be concise. 1. What is the ratio of the Rating (1=low 6=high) in Business regulatory environment in 2008 to that in 2009?
Give a very brief answer. 1. What is the ratio of the Rating (1=low 6=high) of Management rating in 2008 to that in 2009?
Offer a terse response. 1.05. What is the ratio of the Rating (1=low 6=high) in Business regulatory environment in 2008 to that in 2010?
Provide a succinct answer. 1. What is the ratio of the Rating (1=low 6=high) of Debt policy in 2008 to that in 2010?
Your answer should be compact. 1.18. What is the ratio of the Rating (1=low 6=high) in Management rating in 2008 to that in 2010?
Your answer should be compact. 1.05. What is the ratio of the Rating (1=low 6=high) of Building human resources in 2008 to that in 2011?
Provide a succinct answer. 1.08. What is the ratio of the Rating (1=low 6=high) in Management rating in 2008 to that in 2011?
Keep it short and to the point. 1.08. What is the ratio of the Rating (1=low 6=high) of Business regulatory environment in 2008 to that in 2012?
Provide a short and direct response. 1.08. What is the ratio of the Rating (1=low 6=high) in Management rating in 2008 to that in 2012?
Make the answer very short. 1.03. What is the ratio of the Rating (1=low 6=high) of Building human resources in 2008 to that in 2013?
Your answer should be very brief. 1. What is the ratio of the Rating (1=low 6=high) of Debt policy in 2008 to that in 2013?
Your answer should be compact. 1.08. What is the ratio of the Rating (1=low 6=high) in Management rating in 2008 to that in 2013?
Give a very brief answer. 1.03. What is the ratio of the Rating (1=low 6=high) of Building human resources in 2009 to that in 2010?
Offer a very short reply. 1. What is the ratio of the Rating (1=low 6=high) of Debt policy in 2009 to that in 2010?
Ensure brevity in your answer.  1.09. What is the ratio of the Rating (1=low 6=high) in Management rating in 2009 to that in 2010?
Provide a succinct answer. 1. What is the ratio of the Rating (1=low 6=high) in Management rating in 2009 to that in 2011?
Offer a very short reply. 1.03. What is the ratio of the Rating (1=low 6=high) of Building human resources in 2009 to that in 2012?
Provide a succinct answer. 1. What is the ratio of the Rating (1=low 6=high) in Business regulatory environment in 2009 to that in 2012?
Offer a very short reply. 1.08. What is the ratio of the Rating (1=low 6=high) in Debt policy in 2009 to that in 2012?
Ensure brevity in your answer.  1. What is the ratio of the Rating (1=low 6=high) in Management rating in 2009 to that in 2012?
Offer a very short reply. 0.97. What is the ratio of the Rating (1=low 6=high) in Business regulatory environment in 2009 to that in 2013?
Your response must be concise. 1.08. What is the ratio of the Rating (1=low 6=high) of Debt policy in 2009 to that in 2013?
Your response must be concise. 1. What is the ratio of the Rating (1=low 6=high) in Management rating in 2009 to that in 2013?
Your answer should be very brief. 0.97. What is the ratio of the Rating (1=low 6=high) in Business regulatory environment in 2010 to that in 2011?
Provide a succinct answer. 1.08. What is the ratio of the Rating (1=low 6=high) of Debt policy in 2010 to that in 2011?
Your answer should be very brief. 0.92. What is the ratio of the Rating (1=low 6=high) in Management rating in 2010 to that in 2011?
Your answer should be very brief. 1.03. What is the ratio of the Rating (1=low 6=high) of Business regulatory environment in 2010 to that in 2012?
Give a very brief answer. 1.08. What is the ratio of the Rating (1=low 6=high) of Management rating in 2010 to that in 2012?
Offer a very short reply. 0.97. What is the ratio of the Rating (1=low 6=high) of Building human resources in 2010 to that in 2013?
Provide a succinct answer. 1. What is the ratio of the Rating (1=low 6=high) of Business regulatory environment in 2010 to that in 2013?
Offer a terse response. 1.08. What is the ratio of the Rating (1=low 6=high) in Management rating in 2010 to that in 2013?
Ensure brevity in your answer.  0.97. What is the ratio of the Rating (1=low 6=high) of Business regulatory environment in 2011 to that in 2012?
Ensure brevity in your answer.  1. What is the ratio of the Rating (1=low 6=high) of Debt policy in 2011 to that in 2012?
Your response must be concise. 1. What is the ratio of the Rating (1=low 6=high) in Management rating in 2011 to that in 2012?
Your answer should be very brief. 0.95. What is the ratio of the Rating (1=low 6=high) of Management rating in 2011 to that in 2013?
Ensure brevity in your answer.  0.95. What is the ratio of the Rating (1=low 6=high) in Building human resources in 2012 to that in 2013?
Your answer should be very brief. 1. What is the ratio of the Rating (1=low 6=high) in Business regulatory environment in 2012 to that in 2013?
Your response must be concise. 1. What is the difference between the highest and the second highest Rating (1=low 6=high) in Management rating?
Your answer should be compact. 0.25. What is the difference between the highest and the lowest Rating (1=low 6=high) of Management rating?
Offer a terse response. 0.5. 